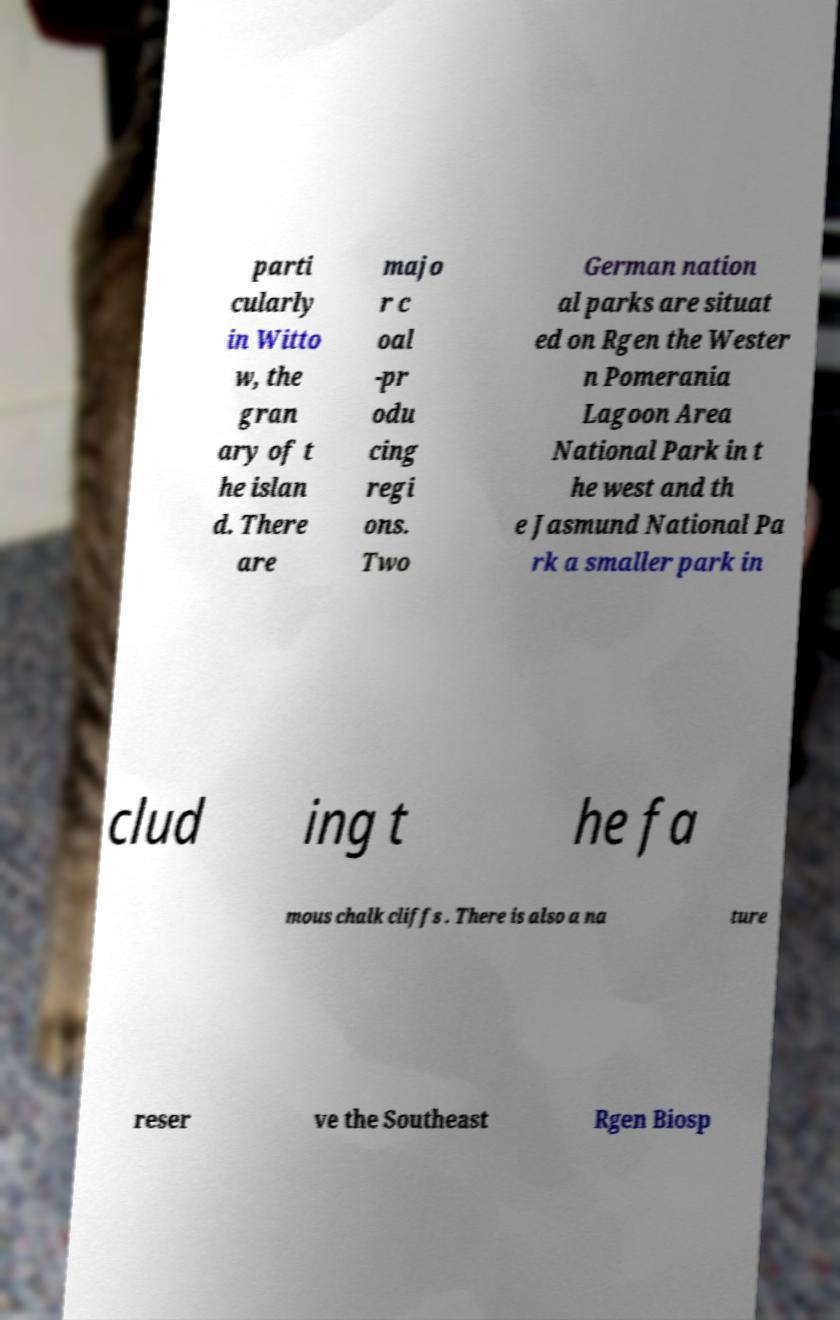Could you assist in decoding the text presented in this image and type it out clearly? parti cularly in Witto w, the gran ary of t he islan d. There are majo r c oal -pr odu cing regi ons. Two German nation al parks are situat ed on Rgen the Wester n Pomerania Lagoon Area National Park in t he west and th e Jasmund National Pa rk a smaller park in clud ing t he fa mous chalk cliffs . There is also a na ture reser ve the Southeast Rgen Biosp 